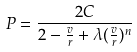<formula> <loc_0><loc_0><loc_500><loc_500>P = \frac { 2 C } { 2 - \frac { v } { r } + \lambda ( \frac { v } { r } ) ^ { n } }</formula> 